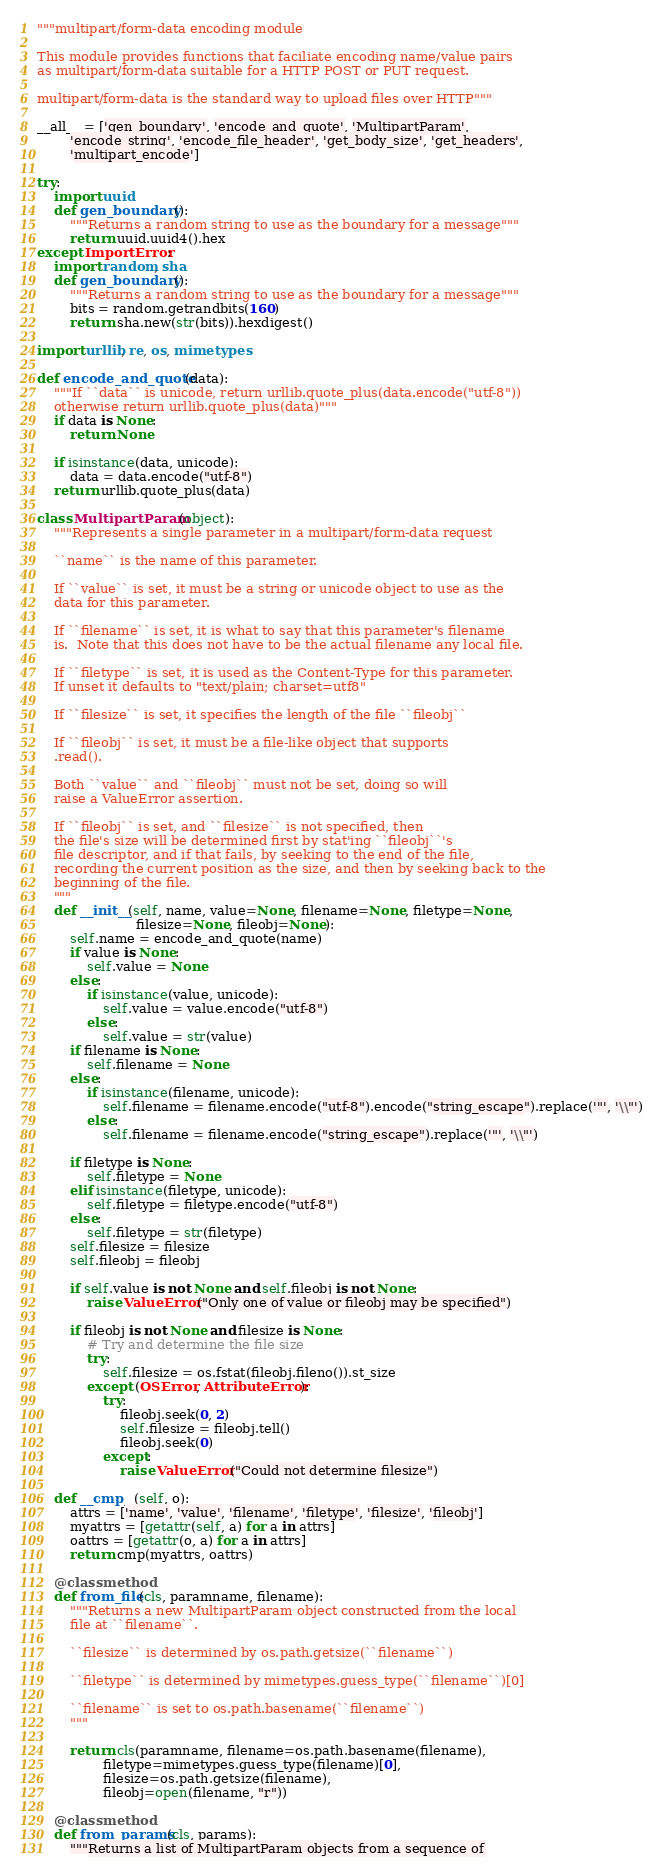<code> <loc_0><loc_0><loc_500><loc_500><_Python_>"""multipart/form-data encoding module

This module provides functions that faciliate encoding name/value pairs
as multipart/form-data suitable for a HTTP POST or PUT request.

multipart/form-data is the standard way to upload files over HTTP"""

__all__ = ['gen_boundary', 'encode_and_quote', 'MultipartParam',
        'encode_string', 'encode_file_header', 'get_body_size', 'get_headers',
        'multipart_encode']

try:
    import uuid
    def gen_boundary():
        """Returns a random string to use as the boundary for a message"""
        return uuid.uuid4().hex
except ImportError:
    import random, sha
    def gen_boundary():
        """Returns a random string to use as the boundary for a message"""
        bits = random.getrandbits(160)
        return sha.new(str(bits)).hexdigest()

import urllib, re, os, mimetypes

def encode_and_quote(data):
    """If ``data`` is unicode, return urllib.quote_plus(data.encode("utf-8"))
    otherwise return urllib.quote_plus(data)"""
    if data is None:
        return None

    if isinstance(data, unicode):
        data = data.encode("utf-8")
    return urllib.quote_plus(data)

class MultipartParam(object):
    """Represents a single parameter in a multipart/form-data request

    ``name`` is the name of this parameter.

    If ``value`` is set, it must be a string or unicode object to use as the
    data for this parameter.

    If ``filename`` is set, it is what to say that this parameter's filename
    is.  Note that this does not have to be the actual filename any local file.

    If ``filetype`` is set, it is used as the Content-Type for this parameter.
    If unset it defaults to "text/plain; charset=utf8"

    If ``filesize`` is set, it specifies the length of the file ``fileobj``

    If ``fileobj`` is set, it must be a file-like object that supports
    .read().

    Both ``value`` and ``fileobj`` must not be set, doing so will
    raise a ValueError assertion.

    If ``fileobj`` is set, and ``filesize`` is not specified, then
    the file's size will be determined first by stat'ing ``fileobj``'s
    file descriptor, and if that fails, by seeking to the end of the file,
    recording the current position as the size, and then by seeking back to the
    beginning of the file.
    """
    def __init__(self, name, value=None, filename=None, filetype=None,
                        filesize=None, fileobj=None):
        self.name = encode_and_quote(name)
        if value is None:
            self.value = None
        else:
            if isinstance(value, unicode):
                self.value = value.encode("utf-8")
            else:
                self.value = str(value)
        if filename is None:
            self.filename = None
        else:
            if isinstance(filename, unicode):
                self.filename = filename.encode("utf-8").encode("string_escape").replace('"', '\\"')
            else:
                self.filename = filename.encode("string_escape").replace('"', '\\"')

        if filetype is None:
            self.filetype = None
        elif isinstance(filetype, unicode):
            self.filetype = filetype.encode("utf-8")
        else:
            self.filetype = str(filetype)
        self.filesize = filesize
        self.fileobj = fileobj

        if self.value is not None and self.fileobj is not None:
            raise ValueError("Only one of value or fileobj may be specified")

        if fileobj is not None and filesize is None:
            # Try and determine the file size
            try:
                self.filesize = os.fstat(fileobj.fileno()).st_size
            except (OSError, AttributeError):
                try:
                    fileobj.seek(0, 2)
                    self.filesize = fileobj.tell()
                    fileobj.seek(0)
                except:
                    raise ValueError("Could not determine filesize")

    def __cmp__(self, o):
        attrs = ['name', 'value', 'filename', 'filetype', 'filesize', 'fileobj']
        myattrs = [getattr(self, a) for a in attrs]
        oattrs = [getattr(o, a) for a in attrs]
        return cmp(myattrs, oattrs)

    @classmethod
    def from_file(cls, paramname, filename):
        """Returns a new MultipartParam object constructed from the local
        file at ``filename``.

        ``filesize`` is determined by os.path.getsize(``filename``)

        ``filetype`` is determined by mimetypes.guess_type(``filename``)[0]

        ``filename`` is set to os.path.basename(``filename``)
        """

        return cls(paramname, filename=os.path.basename(filename),
                filetype=mimetypes.guess_type(filename)[0],
                filesize=os.path.getsize(filename),
                fileobj=open(filename, "r"))

    @classmethod
    def from_params(cls, params):
        """Returns a list of MultipartParam objects from a sequence of</code> 